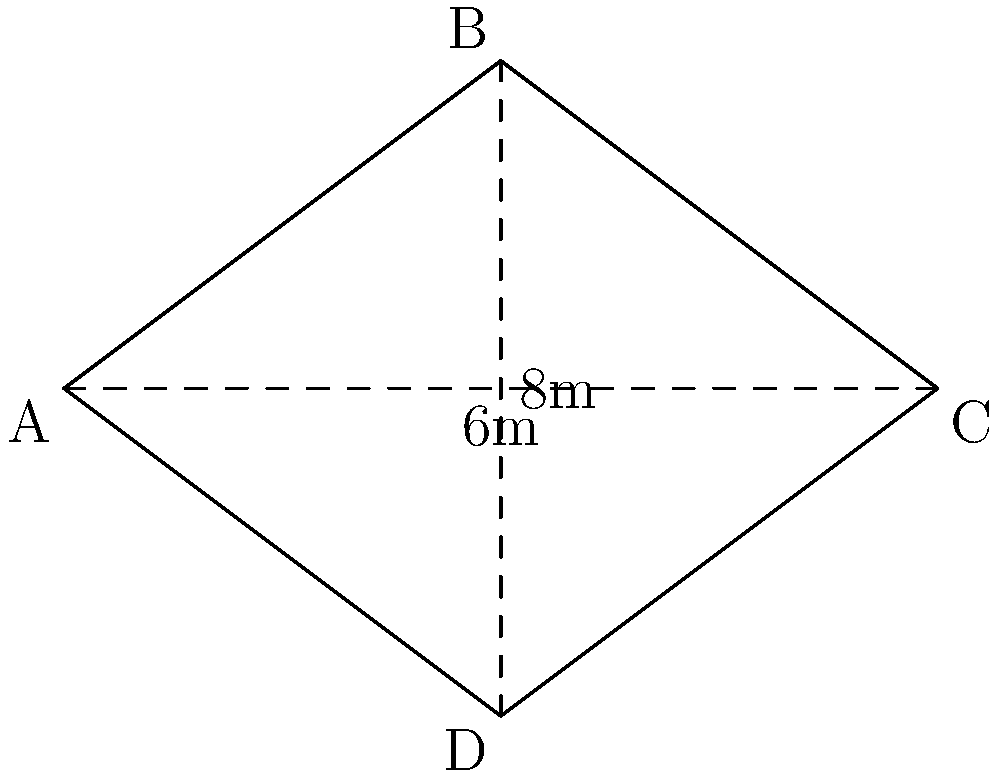In a Georgian cinema featuring Otar Megvinetukhutsesi's films, the screen is shaped like a rhombus. If the diagonals of the rhombus-shaped screen measure 6m and 8m, what is the area of the screen in square meters? To find the area of a rhombus given its diagonals, we can use the formula:

$$A = \frac{d_1 \times d_2}{2}$$

Where $A$ is the area, and $d_1$ and $d_2$ are the lengths of the diagonals.

Step 1: Identify the given information
- Diagonal 1 ($d_1$) = 6m
- Diagonal 2 ($d_2$) = 8m

Step 2: Substitute the values into the formula
$$A = \frac{6m \times 8m}{2}$$

Step 3: Multiply the numerator
$$A = \frac{48m^2}{2}$$

Step 4: Divide to get the final answer
$$A = 24m^2$$

Therefore, the area of the rhombus-shaped cinema screen is 24 square meters.
Answer: $24m^2$ 